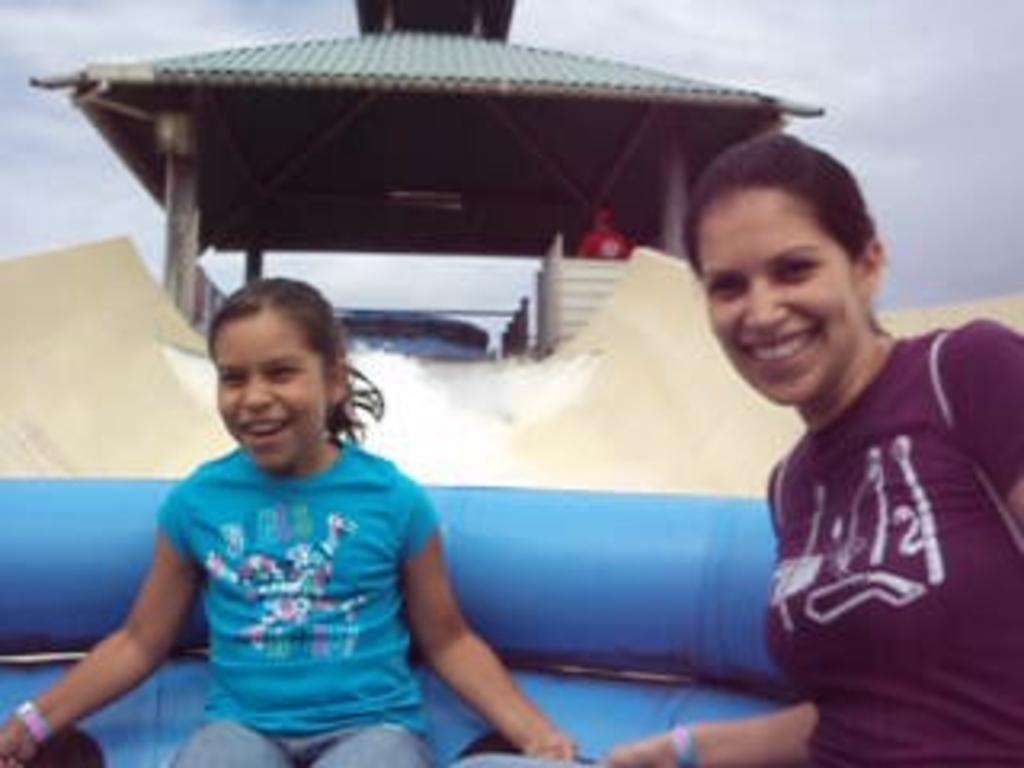How would you summarize this image in a sentence or two? In this picture I can see two persons sitting in an inflatable tube, which is on the slider, there is water, there is a shed, and in the background there is the sky. 